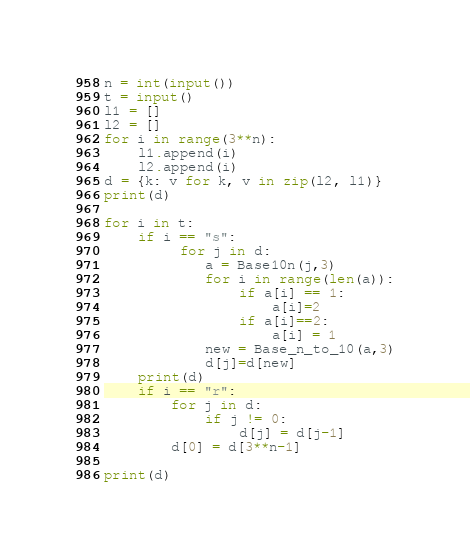<code> <loc_0><loc_0><loc_500><loc_500><_Python_>n = int(input())
t = input()      
l1 = []
l2 = []
for i in range(3**n):
    l1.append(i)
    l2.append(i)
d = {k: v for k, v in zip(l2, l1)}
print(d)

for i in t:
    if i == "s":
         for j in d:
            a = Base10n(j,3)
            for i in range(len(a)):
                if a[i] == 1:
                    a[i]=2
                if a[i]==2:
                    a[i] = 1
            new = Base_n_to_10(a,3)
            d[j]=d[new]
    print(d)
    if i == "r":
        for j in d:
            if j != 0:
                d[j] = d[j-1]
        d[0] = d[3**n-1]
         
print(d)</code> 